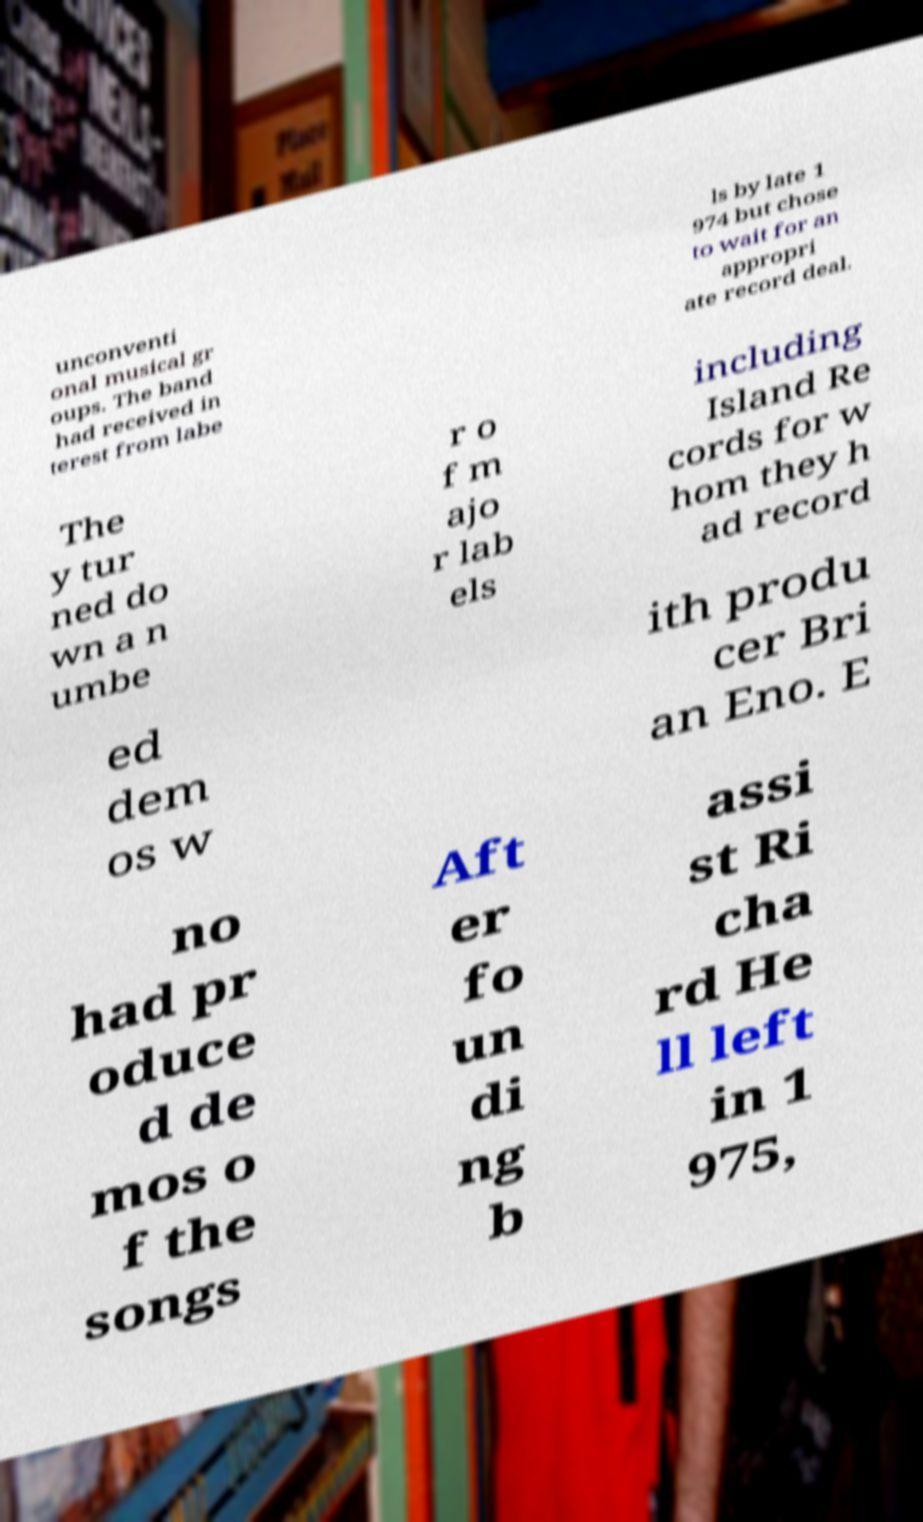Could you extract and type out the text from this image? unconventi onal musical gr oups. The band had received in terest from labe ls by late 1 974 but chose to wait for an appropri ate record deal. The y tur ned do wn a n umbe r o f m ajo r lab els including Island Re cords for w hom they h ad record ed dem os w ith produ cer Bri an Eno. E no had pr oduce d de mos o f the songs Aft er fo un di ng b assi st Ri cha rd He ll left in 1 975, 